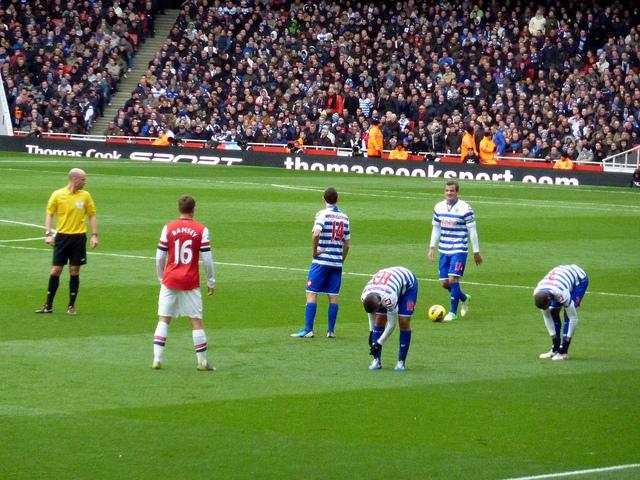What color is the ball?
Give a very brief answer. Yellow. How many players are on the field?
Concise answer only. 6. What game are they playing?
Give a very brief answer. Soccer. Are there any spectators?
Quick response, please. Yes. 